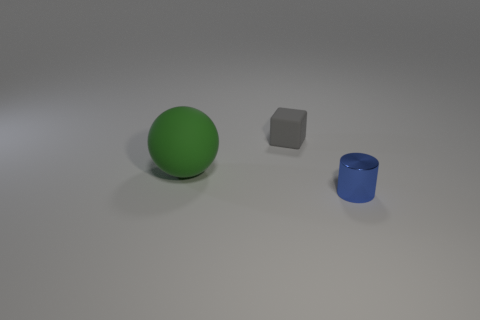What colors are present in the objects on the surface? The objects include a green sphere, a gray block, and a blue cylinder. 